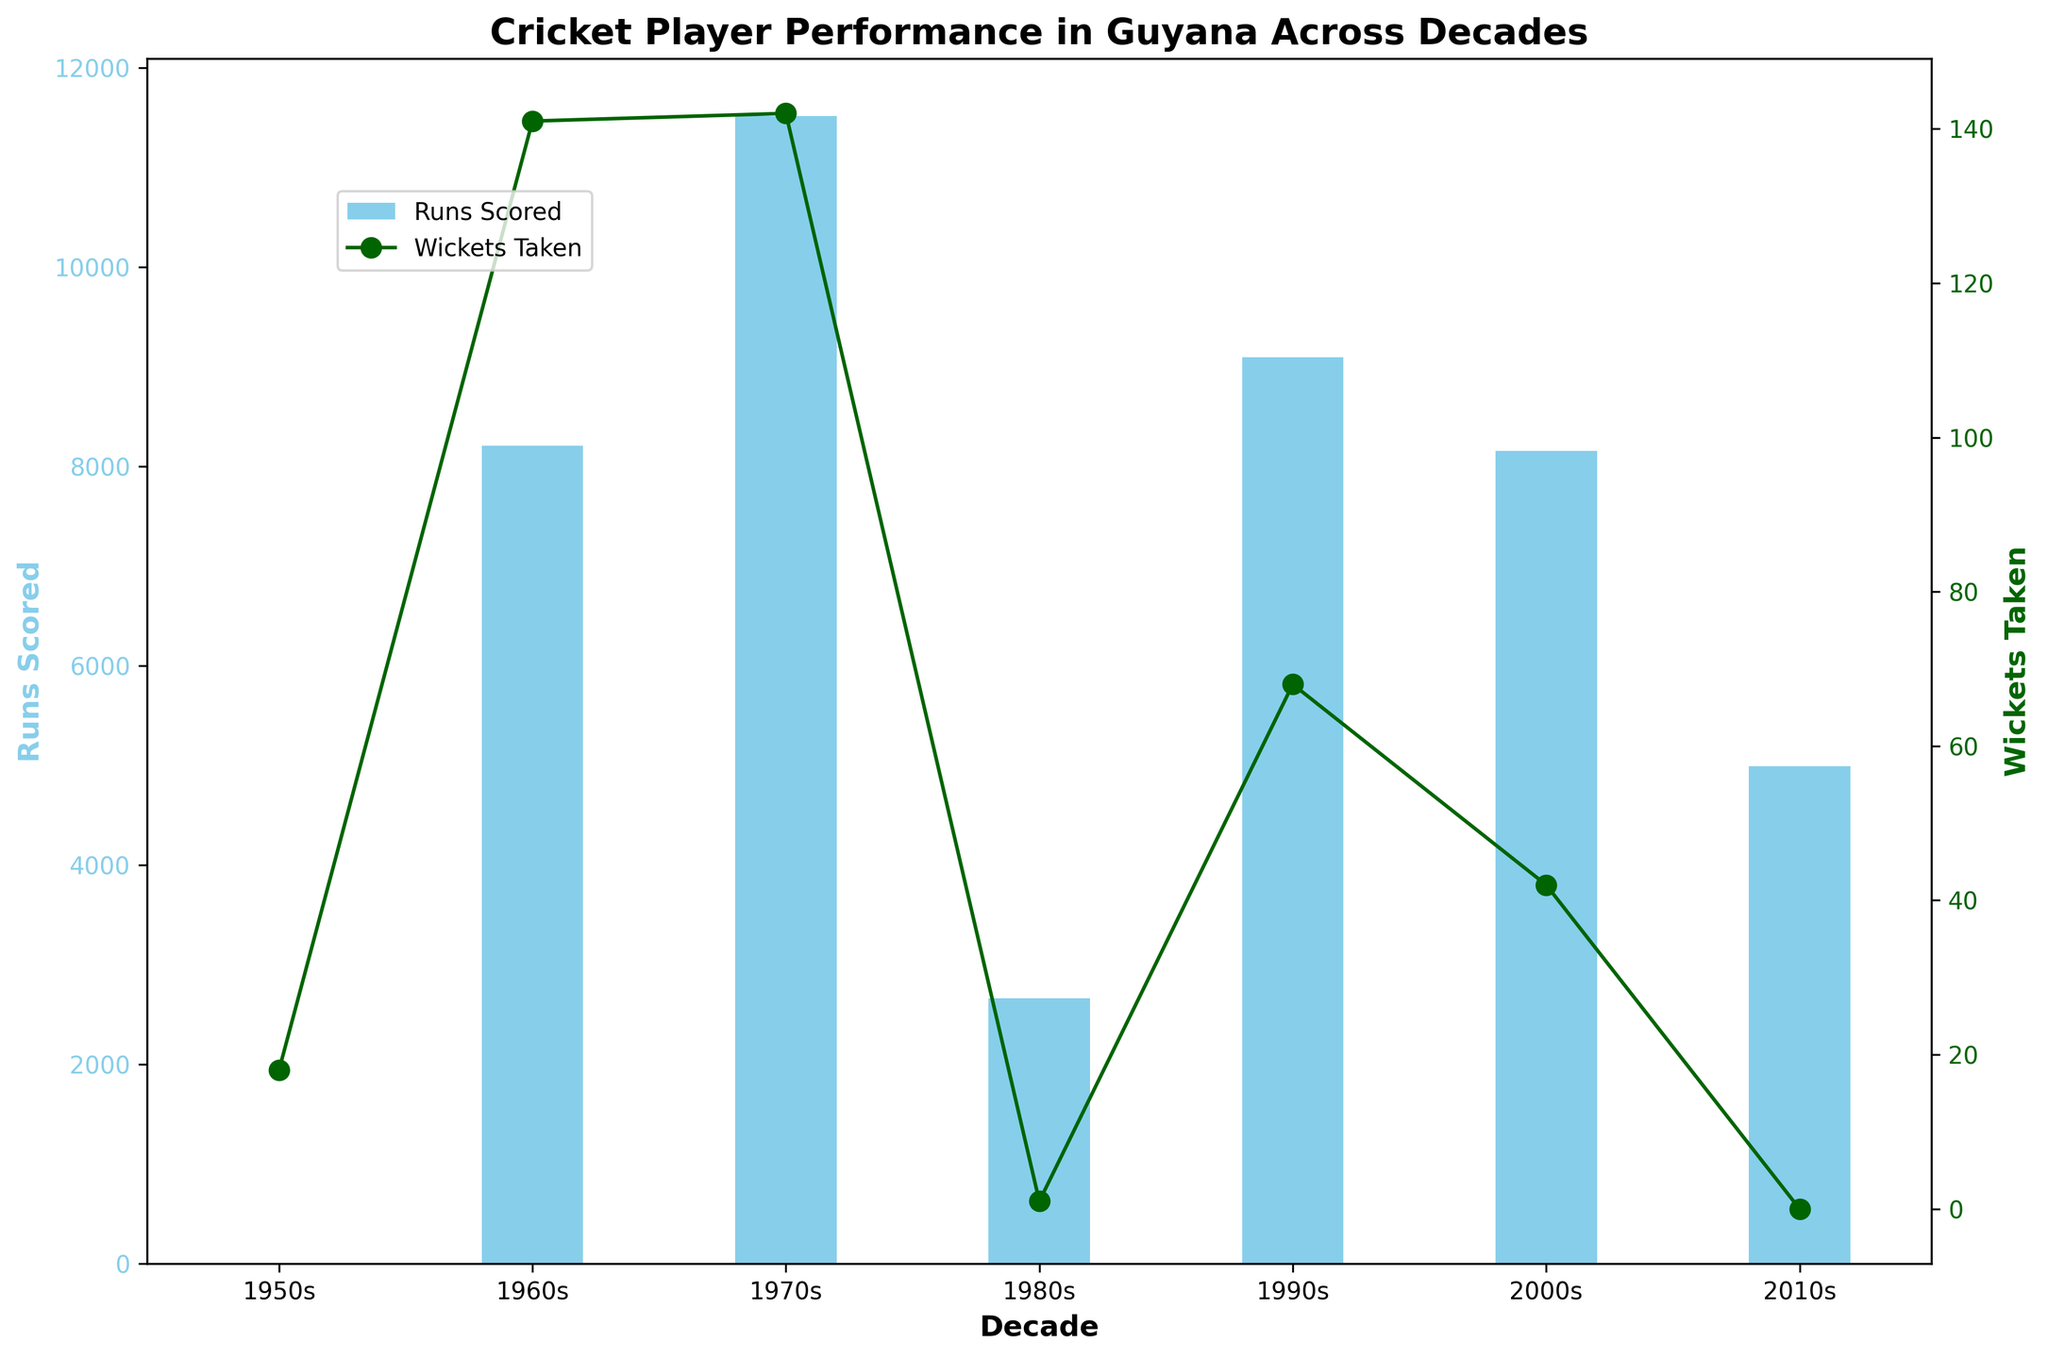Which decade had the highest number of runs scored? Look at the bar heights for "Runs Scored" across different decades and identify the tallest one. The 2000s have the highest bar.
Answer: 2000s Which decade had the highest number of wickets taken? Refer to the line plot for "Wickets Taken" and find the peak point. The 1960s have the highest point.
Answer: 1960s How many runs were scored in total in the 1970s? Add up the runs scored by all players in the 1970s. From the plot, the total is approximately 4390 (Kallicharran) + 5238 (Lloyd) + 1620 (Kanhai) + 267 (Gibbs) = 11,515.
Answer: 11,515 How does the number of runs scored in the 2010s compare with the 1990s? Compare the height of the bars representing "Runs Scored" for the 2010s and 1990s. The 1990s have a taller bar (approx. ~14,989 vs. ~10,648).
Answer: Runs scored in the 2010s are less than those in the 1990s What is the difference between the wickets taken in the 1960s and the 2000s? Find the values from the line plot for "Wickets Taken" in the 1960s and 2000s, then subtract the 2000s from the 1960s. Values are ~155 (1960s) - ~42 (2000s) = 113.
Answer: 113 How much higher is the number of runs scored in the 2000s compared to the 2010s? Subtract the total runs scored in the 2010s from that in the 2000s (from bar heights). Values are ~2000s: 10,416 - ~2010s: 10,648 = 2,437.
Answer: 2,437 Which decade had the least number of wickets taken? Identify the lowest point in the line plot for "Wickets Taken" across different decades. The 1980s have the lowest point.
Answer: 1980s 